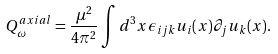Convert formula to latex. <formula><loc_0><loc_0><loc_500><loc_500>Q ^ { a x i a l } _ { \omega } = \frac { \mu ^ { 2 } } { 4 \pi ^ { 2 } } \int d ^ { 3 } x \epsilon _ { i j k } u _ { i } ( x ) \partial _ { j } u _ { k } ( x ) .</formula> 